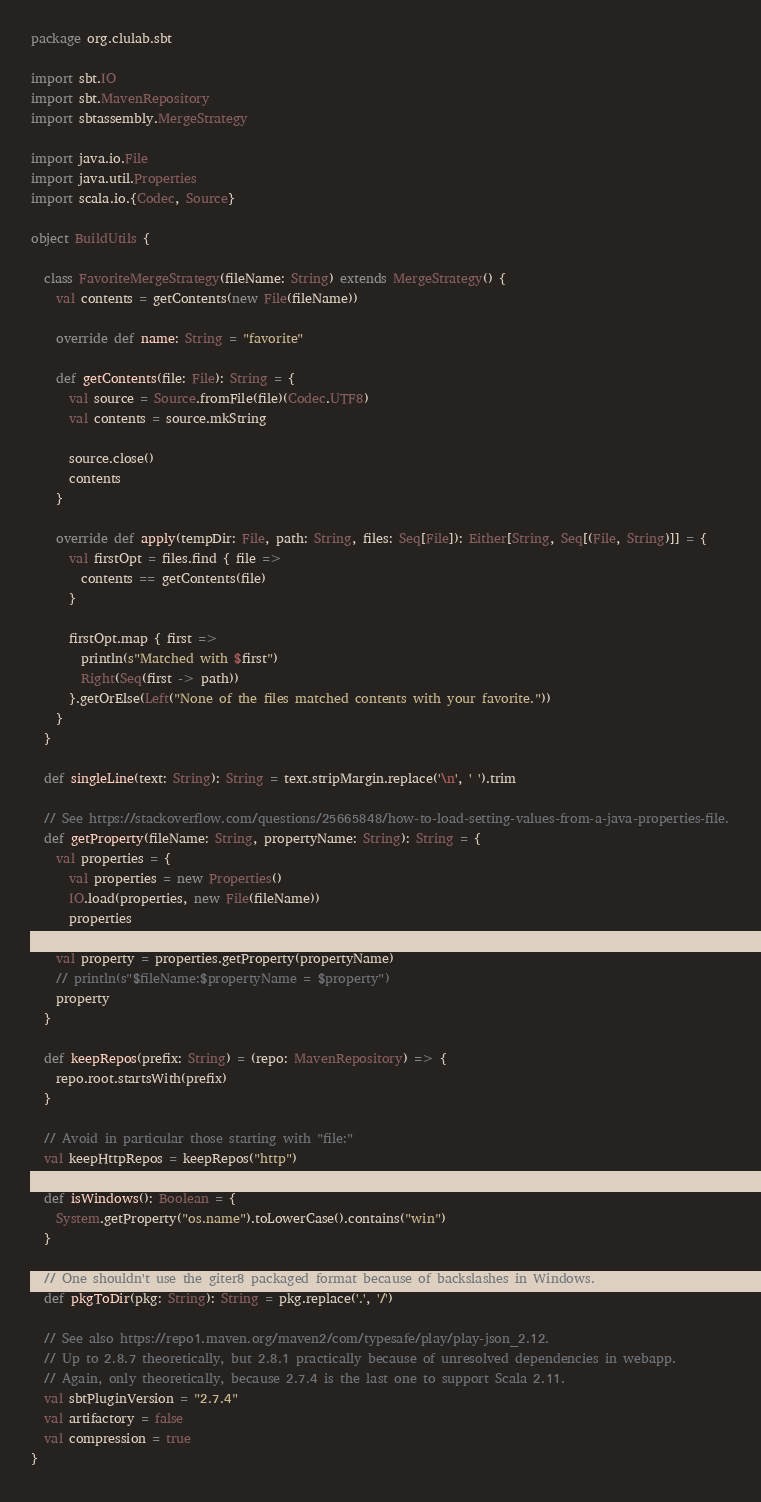Convert code to text. <code><loc_0><loc_0><loc_500><loc_500><_Scala_>package org.clulab.sbt

import sbt.IO
import sbt.MavenRepository
import sbtassembly.MergeStrategy

import java.io.File
import java.util.Properties
import scala.io.{Codec, Source}

object BuildUtils {

  class FavoriteMergeStrategy(fileName: String) extends MergeStrategy() {
    val contents = getContents(new File(fileName))

    override def name: String = "favorite"

    def getContents(file: File): String = {
      val source = Source.fromFile(file)(Codec.UTF8)
      val contents = source.mkString

      source.close()
      contents
    }

    override def apply(tempDir: File, path: String, files: Seq[File]): Either[String, Seq[(File, String)]] = {
      val firstOpt = files.find { file =>
        contents == getContents(file)
      }

      firstOpt.map { first =>
        println(s"Matched with $first")
        Right(Seq(first -> path))
      }.getOrElse(Left("None of the files matched contents with your favorite."))
    }
  }

  def singleLine(text: String): String = text.stripMargin.replace('\n', ' ').trim

  // See https://stackoverflow.com/questions/25665848/how-to-load-setting-values-from-a-java-properties-file.
  def getProperty(fileName: String, propertyName: String): String = {
    val properties = {
      val properties = new Properties()
      IO.load(properties, new File(fileName))
      properties
    }
    val property = properties.getProperty(propertyName)
    // println(s"$fileName:$propertyName = $property")
    property
  }

  def keepRepos(prefix: String) = (repo: MavenRepository) => {
    repo.root.startsWith(prefix)
  }

  // Avoid in particular those starting with "file:"
  val keepHttpRepos = keepRepos("http")

  def isWindows(): Boolean = {
    System.getProperty("os.name").toLowerCase().contains("win")
  }

  // One shouldn't use the giter8 packaged format because of backslashes in Windows.
  def pkgToDir(pkg: String): String = pkg.replace('.', '/')

  // See also https://repo1.maven.org/maven2/com/typesafe/play/play-json_2.12.
  // Up to 2.8.7 theoretically, but 2.8.1 practically because of unresolved dependencies in webapp.
  // Again, only theoretically, because 2.7.4 is the last one to support Scala 2.11.
  val sbtPluginVersion = "2.7.4"
  val artifactory = false
  val compression = true
}
</code> 